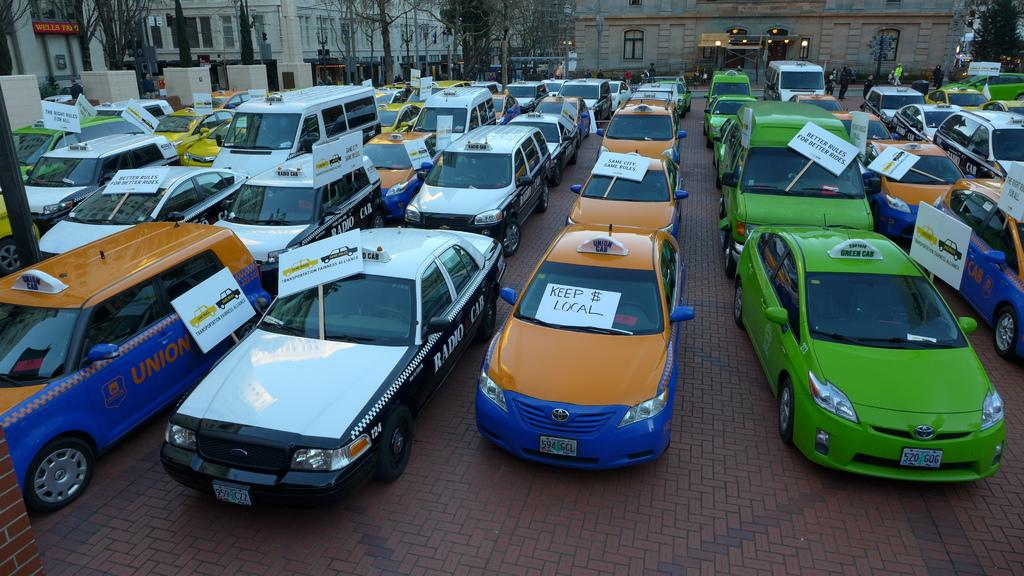<image>
Provide a brief description of the given image. a lot filled with cars with signs like Keep $ Local on them 